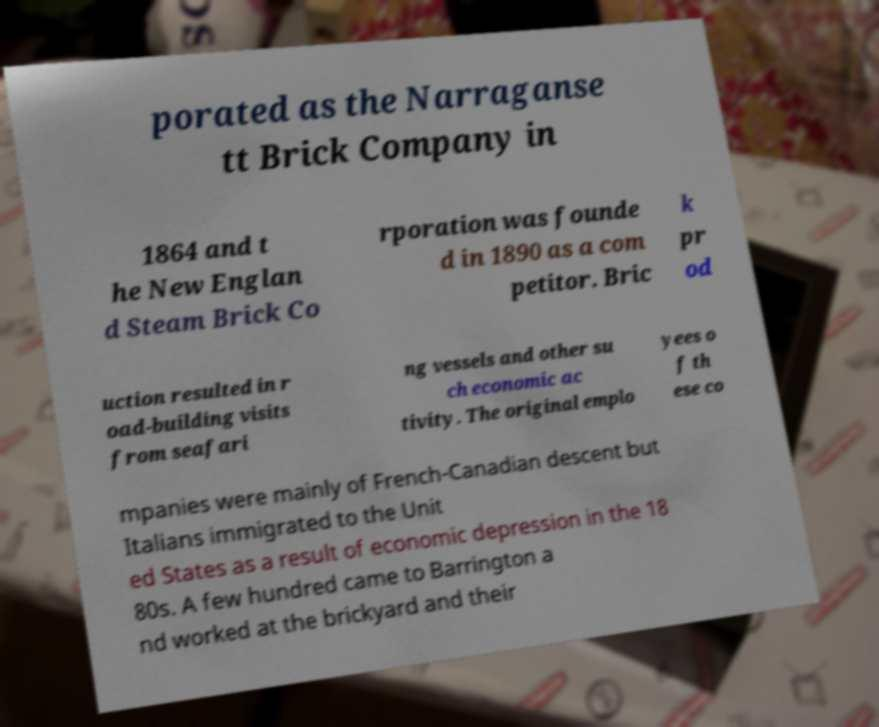There's text embedded in this image that I need extracted. Can you transcribe it verbatim? porated as the Narraganse tt Brick Company in 1864 and t he New Englan d Steam Brick Co rporation was founde d in 1890 as a com petitor. Bric k pr od uction resulted in r oad-building visits from seafari ng vessels and other su ch economic ac tivity. The original emplo yees o f th ese co mpanies were mainly of French-Canadian descent but Italians immigrated to the Unit ed States as a result of economic depression in the 18 80s. A few hundred came to Barrington a nd worked at the brickyard and their 